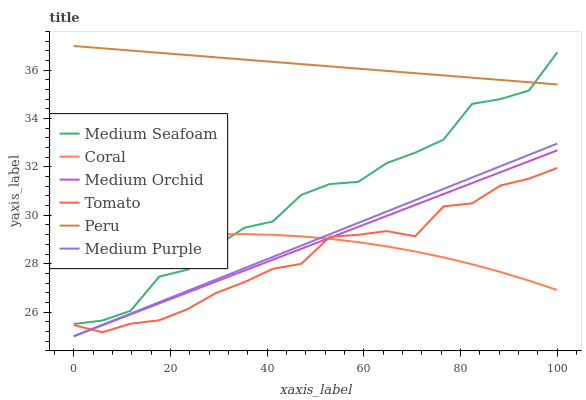Does Tomato have the minimum area under the curve?
Answer yes or no. Yes. Does Peru have the maximum area under the curve?
Answer yes or no. Yes. Does Coral have the minimum area under the curve?
Answer yes or no. No. Does Coral have the maximum area under the curve?
Answer yes or no. No. Is Medium Purple the smoothest?
Answer yes or no. Yes. Is Medium Seafoam the roughest?
Answer yes or no. Yes. Is Coral the smoothest?
Answer yes or no. No. Is Coral the roughest?
Answer yes or no. No. Does Medium Orchid have the lowest value?
Answer yes or no. Yes. Does Coral have the lowest value?
Answer yes or no. No. Does Peru have the highest value?
Answer yes or no. Yes. Does Medium Orchid have the highest value?
Answer yes or no. No. Is Medium Purple less than Peru?
Answer yes or no. Yes. Is Peru greater than Tomato?
Answer yes or no. Yes. Does Medium Orchid intersect Medium Purple?
Answer yes or no. Yes. Is Medium Orchid less than Medium Purple?
Answer yes or no. No. Is Medium Orchid greater than Medium Purple?
Answer yes or no. No. Does Medium Purple intersect Peru?
Answer yes or no. No. 